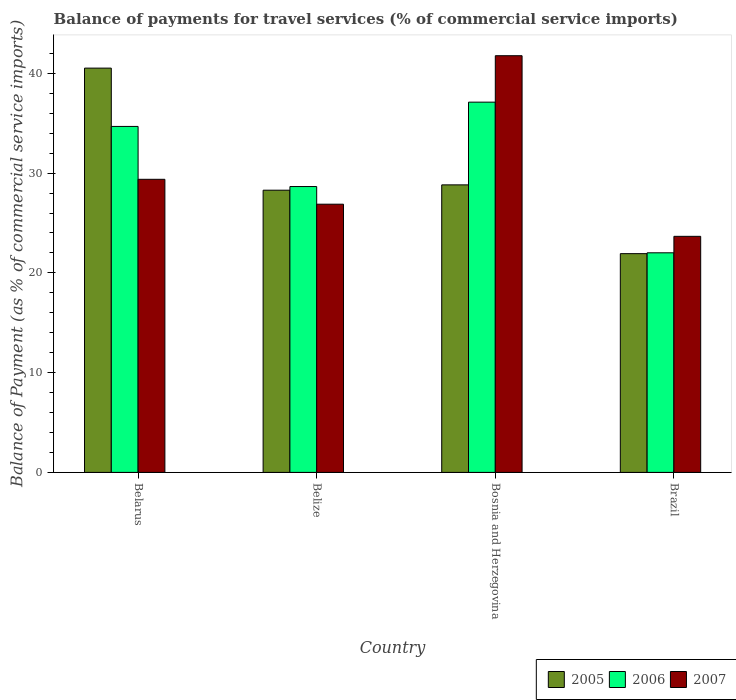How many groups of bars are there?
Provide a short and direct response. 4. How many bars are there on the 3rd tick from the left?
Give a very brief answer. 3. What is the label of the 3rd group of bars from the left?
Your response must be concise. Bosnia and Herzegovina. In how many cases, is the number of bars for a given country not equal to the number of legend labels?
Your response must be concise. 0. What is the balance of payments for travel services in 2005 in Bosnia and Herzegovina?
Ensure brevity in your answer.  28.82. Across all countries, what is the maximum balance of payments for travel services in 2006?
Your answer should be compact. 37.12. Across all countries, what is the minimum balance of payments for travel services in 2005?
Offer a terse response. 21.93. In which country was the balance of payments for travel services in 2006 maximum?
Keep it short and to the point. Bosnia and Herzegovina. What is the total balance of payments for travel services in 2006 in the graph?
Offer a very short reply. 122.47. What is the difference between the balance of payments for travel services in 2005 in Belize and that in Bosnia and Herzegovina?
Your answer should be very brief. -0.53. What is the difference between the balance of payments for travel services in 2005 in Brazil and the balance of payments for travel services in 2006 in Belize?
Provide a succinct answer. -6.73. What is the average balance of payments for travel services in 2006 per country?
Your response must be concise. 30.62. What is the difference between the balance of payments for travel services of/in 2007 and balance of payments for travel services of/in 2005 in Brazil?
Make the answer very short. 1.74. In how many countries, is the balance of payments for travel services in 2006 greater than 2 %?
Offer a very short reply. 4. What is the ratio of the balance of payments for travel services in 2007 in Belarus to that in Bosnia and Herzegovina?
Your answer should be compact. 0.7. Is the balance of payments for travel services in 2007 in Belize less than that in Bosnia and Herzegovina?
Provide a short and direct response. Yes. What is the difference between the highest and the second highest balance of payments for travel services in 2006?
Offer a terse response. 6.03. What is the difference between the highest and the lowest balance of payments for travel services in 2007?
Ensure brevity in your answer.  18.11. In how many countries, is the balance of payments for travel services in 2007 greater than the average balance of payments for travel services in 2007 taken over all countries?
Give a very brief answer. 1. How many bars are there?
Your response must be concise. 12. Are all the bars in the graph horizontal?
Your response must be concise. No. Are the values on the major ticks of Y-axis written in scientific E-notation?
Provide a succinct answer. No. Where does the legend appear in the graph?
Provide a succinct answer. Bottom right. How many legend labels are there?
Your answer should be very brief. 3. How are the legend labels stacked?
Give a very brief answer. Horizontal. What is the title of the graph?
Offer a very short reply. Balance of payments for travel services (% of commercial service imports). What is the label or title of the Y-axis?
Provide a succinct answer. Balance of Payment (as % of commercial service imports). What is the Balance of Payment (as % of commercial service imports) of 2005 in Belarus?
Provide a succinct answer. 40.53. What is the Balance of Payment (as % of commercial service imports) in 2006 in Belarus?
Your answer should be very brief. 34.68. What is the Balance of Payment (as % of commercial service imports) in 2007 in Belarus?
Give a very brief answer. 29.38. What is the Balance of Payment (as % of commercial service imports) of 2005 in Belize?
Your answer should be very brief. 28.29. What is the Balance of Payment (as % of commercial service imports) of 2006 in Belize?
Provide a short and direct response. 28.66. What is the Balance of Payment (as % of commercial service imports) of 2007 in Belize?
Offer a very short reply. 26.89. What is the Balance of Payment (as % of commercial service imports) in 2005 in Bosnia and Herzegovina?
Offer a terse response. 28.82. What is the Balance of Payment (as % of commercial service imports) of 2006 in Bosnia and Herzegovina?
Provide a succinct answer. 37.12. What is the Balance of Payment (as % of commercial service imports) of 2007 in Bosnia and Herzegovina?
Your response must be concise. 41.77. What is the Balance of Payment (as % of commercial service imports) of 2005 in Brazil?
Your response must be concise. 21.93. What is the Balance of Payment (as % of commercial service imports) of 2006 in Brazil?
Make the answer very short. 22.01. What is the Balance of Payment (as % of commercial service imports) of 2007 in Brazil?
Your response must be concise. 23.66. Across all countries, what is the maximum Balance of Payment (as % of commercial service imports) in 2005?
Ensure brevity in your answer.  40.53. Across all countries, what is the maximum Balance of Payment (as % of commercial service imports) of 2006?
Your answer should be very brief. 37.12. Across all countries, what is the maximum Balance of Payment (as % of commercial service imports) of 2007?
Keep it short and to the point. 41.77. Across all countries, what is the minimum Balance of Payment (as % of commercial service imports) in 2005?
Ensure brevity in your answer.  21.93. Across all countries, what is the minimum Balance of Payment (as % of commercial service imports) of 2006?
Keep it short and to the point. 22.01. Across all countries, what is the minimum Balance of Payment (as % of commercial service imports) of 2007?
Offer a terse response. 23.66. What is the total Balance of Payment (as % of commercial service imports) in 2005 in the graph?
Your response must be concise. 119.57. What is the total Balance of Payment (as % of commercial service imports) in 2006 in the graph?
Your response must be concise. 122.47. What is the total Balance of Payment (as % of commercial service imports) of 2007 in the graph?
Keep it short and to the point. 121.7. What is the difference between the Balance of Payment (as % of commercial service imports) in 2005 in Belarus and that in Belize?
Your answer should be very brief. 12.24. What is the difference between the Balance of Payment (as % of commercial service imports) of 2006 in Belarus and that in Belize?
Offer a terse response. 6.03. What is the difference between the Balance of Payment (as % of commercial service imports) of 2007 in Belarus and that in Belize?
Give a very brief answer. 2.49. What is the difference between the Balance of Payment (as % of commercial service imports) in 2005 in Belarus and that in Bosnia and Herzegovina?
Provide a succinct answer. 11.7. What is the difference between the Balance of Payment (as % of commercial service imports) in 2006 in Belarus and that in Bosnia and Herzegovina?
Provide a succinct answer. -2.43. What is the difference between the Balance of Payment (as % of commercial service imports) of 2007 in Belarus and that in Bosnia and Herzegovina?
Offer a terse response. -12.39. What is the difference between the Balance of Payment (as % of commercial service imports) in 2005 in Belarus and that in Brazil?
Your answer should be compact. 18.6. What is the difference between the Balance of Payment (as % of commercial service imports) in 2006 in Belarus and that in Brazil?
Make the answer very short. 12.67. What is the difference between the Balance of Payment (as % of commercial service imports) in 2007 in Belarus and that in Brazil?
Your response must be concise. 5.72. What is the difference between the Balance of Payment (as % of commercial service imports) in 2005 in Belize and that in Bosnia and Herzegovina?
Your answer should be very brief. -0.53. What is the difference between the Balance of Payment (as % of commercial service imports) in 2006 in Belize and that in Bosnia and Herzegovina?
Offer a very short reply. -8.46. What is the difference between the Balance of Payment (as % of commercial service imports) in 2007 in Belize and that in Bosnia and Herzegovina?
Provide a succinct answer. -14.88. What is the difference between the Balance of Payment (as % of commercial service imports) in 2005 in Belize and that in Brazil?
Offer a terse response. 6.36. What is the difference between the Balance of Payment (as % of commercial service imports) in 2006 in Belize and that in Brazil?
Give a very brief answer. 6.64. What is the difference between the Balance of Payment (as % of commercial service imports) in 2007 in Belize and that in Brazil?
Your response must be concise. 3.22. What is the difference between the Balance of Payment (as % of commercial service imports) of 2005 in Bosnia and Herzegovina and that in Brazil?
Ensure brevity in your answer.  6.9. What is the difference between the Balance of Payment (as % of commercial service imports) in 2006 in Bosnia and Herzegovina and that in Brazil?
Offer a very short reply. 15.1. What is the difference between the Balance of Payment (as % of commercial service imports) of 2007 in Bosnia and Herzegovina and that in Brazil?
Offer a terse response. 18.11. What is the difference between the Balance of Payment (as % of commercial service imports) of 2005 in Belarus and the Balance of Payment (as % of commercial service imports) of 2006 in Belize?
Your response must be concise. 11.87. What is the difference between the Balance of Payment (as % of commercial service imports) in 2005 in Belarus and the Balance of Payment (as % of commercial service imports) in 2007 in Belize?
Provide a succinct answer. 13.64. What is the difference between the Balance of Payment (as % of commercial service imports) in 2006 in Belarus and the Balance of Payment (as % of commercial service imports) in 2007 in Belize?
Offer a very short reply. 7.8. What is the difference between the Balance of Payment (as % of commercial service imports) of 2005 in Belarus and the Balance of Payment (as % of commercial service imports) of 2006 in Bosnia and Herzegovina?
Your answer should be very brief. 3.41. What is the difference between the Balance of Payment (as % of commercial service imports) of 2005 in Belarus and the Balance of Payment (as % of commercial service imports) of 2007 in Bosnia and Herzegovina?
Provide a succinct answer. -1.24. What is the difference between the Balance of Payment (as % of commercial service imports) in 2006 in Belarus and the Balance of Payment (as % of commercial service imports) in 2007 in Bosnia and Herzegovina?
Offer a terse response. -7.09. What is the difference between the Balance of Payment (as % of commercial service imports) of 2005 in Belarus and the Balance of Payment (as % of commercial service imports) of 2006 in Brazil?
Your answer should be very brief. 18.51. What is the difference between the Balance of Payment (as % of commercial service imports) in 2005 in Belarus and the Balance of Payment (as % of commercial service imports) in 2007 in Brazil?
Give a very brief answer. 16.86. What is the difference between the Balance of Payment (as % of commercial service imports) in 2006 in Belarus and the Balance of Payment (as % of commercial service imports) in 2007 in Brazil?
Ensure brevity in your answer.  11.02. What is the difference between the Balance of Payment (as % of commercial service imports) of 2005 in Belize and the Balance of Payment (as % of commercial service imports) of 2006 in Bosnia and Herzegovina?
Offer a terse response. -8.83. What is the difference between the Balance of Payment (as % of commercial service imports) of 2005 in Belize and the Balance of Payment (as % of commercial service imports) of 2007 in Bosnia and Herzegovina?
Give a very brief answer. -13.48. What is the difference between the Balance of Payment (as % of commercial service imports) in 2006 in Belize and the Balance of Payment (as % of commercial service imports) in 2007 in Bosnia and Herzegovina?
Ensure brevity in your answer.  -13.12. What is the difference between the Balance of Payment (as % of commercial service imports) in 2005 in Belize and the Balance of Payment (as % of commercial service imports) in 2006 in Brazil?
Provide a succinct answer. 6.28. What is the difference between the Balance of Payment (as % of commercial service imports) of 2005 in Belize and the Balance of Payment (as % of commercial service imports) of 2007 in Brazil?
Offer a very short reply. 4.63. What is the difference between the Balance of Payment (as % of commercial service imports) of 2006 in Belize and the Balance of Payment (as % of commercial service imports) of 2007 in Brazil?
Offer a very short reply. 4.99. What is the difference between the Balance of Payment (as % of commercial service imports) in 2005 in Bosnia and Herzegovina and the Balance of Payment (as % of commercial service imports) in 2006 in Brazil?
Ensure brevity in your answer.  6.81. What is the difference between the Balance of Payment (as % of commercial service imports) of 2005 in Bosnia and Herzegovina and the Balance of Payment (as % of commercial service imports) of 2007 in Brazil?
Offer a very short reply. 5.16. What is the difference between the Balance of Payment (as % of commercial service imports) of 2006 in Bosnia and Herzegovina and the Balance of Payment (as % of commercial service imports) of 2007 in Brazil?
Your answer should be compact. 13.45. What is the average Balance of Payment (as % of commercial service imports) of 2005 per country?
Your response must be concise. 29.89. What is the average Balance of Payment (as % of commercial service imports) in 2006 per country?
Provide a succinct answer. 30.62. What is the average Balance of Payment (as % of commercial service imports) of 2007 per country?
Offer a terse response. 30.43. What is the difference between the Balance of Payment (as % of commercial service imports) in 2005 and Balance of Payment (as % of commercial service imports) in 2006 in Belarus?
Provide a succinct answer. 5.85. What is the difference between the Balance of Payment (as % of commercial service imports) of 2005 and Balance of Payment (as % of commercial service imports) of 2007 in Belarus?
Offer a very short reply. 11.15. What is the difference between the Balance of Payment (as % of commercial service imports) in 2006 and Balance of Payment (as % of commercial service imports) in 2007 in Belarus?
Provide a short and direct response. 5.3. What is the difference between the Balance of Payment (as % of commercial service imports) in 2005 and Balance of Payment (as % of commercial service imports) in 2006 in Belize?
Provide a short and direct response. -0.37. What is the difference between the Balance of Payment (as % of commercial service imports) of 2005 and Balance of Payment (as % of commercial service imports) of 2007 in Belize?
Make the answer very short. 1.4. What is the difference between the Balance of Payment (as % of commercial service imports) in 2006 and Balance of Payment (as % of commercial service imports) in 2007 in Belize?
Provide a short and direct response. 1.77. What is the difference between the Balance of Payment (as % of commercial service imports) of 2005 and Balance of Payment (as % of commercial service imports) of 2006 in Bosnia and Herzegovina?
Provide a short and direct response. -8.29. What is the difference between the Balance of Payment (as % of commercial service imports) of 2005 and Balance of Payment (as % of commercial service imports) of 2007 in Bosnia and Herzegovina?
Offer a very short reply. -12.95. What is the difference between the Balance of Payment (as % of commercial service imports) of 2006 and Balance of Payment (as % of commercial service imports) of 2007 in Bosnia and Herzegovina?
Your response must be concise. -4.66. What is the difference between the Balance of Payment (as % of commercial service imports) of 2005 and Balance of Payment (as % of commercial service imports) of 2006 in Brazil?
Provide a succinct answer. -0.09. What is the difference between the Balance of Payment (as % of commercial service imports) of 2005 and Balance of Payment (as % of commercial service imports) of 2007 in Brazil?
Provide a short and direct response. -1.74. What is the difference between the Balance of Payment (as % of commercial service imports) of 2006 and Balance of Payment (as % of commercial service imports) of 2007 in Brazil?
Your response must be concise. -1.65. What is the ratio of the Balance of Payment (as % of commercial service imports) of 2005 in Belarus to that in Belize?
Your answer should be compact. 1.43. What is the ratio of the Balance of Payment (as % of commercial service imports) in 2006 in Belarus to that in Belize?
Your answer should be compact. 1.21. What is the ratio of the Balance of Payment (as % of commercial service imports) in 2007 in Belarus to that in Belize?
Ensure brevity in your answer.  1.09. What is the ratio of the Balance of Payment (as % of commercial service imports) of 2005 in Belarus to that in Bosnia and Herzegovina?
Your response must be concise. 1.41. What is the ratio of the Balance of Payment (as % of commercial service imports) in 2006 in Belarus to that in Bosnia and Herzegovina?
Give a very brief answer. 0.93. What is the ratio of the Balance of Payment (as % of commercial service imports) of 2007 in Belarus to that in Bosnia and Herzegovina?
Provide a succinct answer. 0.7. What is the ratio of the Balance of Payment (as % of commercial service imports) of 2005 in Belarus to that in Brazil?
Provide a short and direct response. 1.85. What is the ratio of the Balance of Payment (as % of commercial service imports) of 2006 in Belarus to that in Brazil?
Ensure brevity in your answer.  1.58. What is the ratio of the Balance of Payment (as % of commercial service imports) of 2007 in Belarus to that in Brazil?
Provide a succinct answer. 1.24. What is the ratio of the Balance of Payment (as % of commercial service imports) in 2005 in Belize to that in Bosnia and Herzegovina?
Your response must be concise. 0.98. What is the ratio of the Balance of Payment (as % of commercial service imports) in 2006 in Belize to that in Bosnia and Herzegovina?
Make the answer very short. 0.77. What is the ratio of the Balance of Payment (as % of commercial service imports) of 2007 in Belize to that in Bosnia and Herzegovina?
Your answer should be very brief. 0.64. What is the ratio of the Balance of Payment (as % of commercial service imports) of 2005 in Belize to that in Brazil?
Offer a terse response. 1.29. What is the ratio of the Balance of Payment (as % of commercial service imports) of 2006 in Belize to that in Brazil?
Make the answer very short. 1.3. What is the ratio of the Balance of Payment (as % of commercial service imports) in 2007 in Belize to that in Brazil?
Your answer should be very brief. 1.14. What is the ratio of the Balance of Payment (as % of commercial service imports) of 2005 in Bosnia and Herzegovina to that in Brazil?
Give a very brief answer. 1.31. What is the ratio of the Balance of Payment (as % of commercial service imports) in 2006 in Bosnia and Herzegovina to that in Brazil?
Make the answer very short. 1.69. What is the ratio of the Balance of Payment (as % of commercial service imports) in 2007 in Bosnia and Herzegovina to that in Brazil?
Provide a succinct answer. 1.77. What is the difference between the highest and the second highest Balance of Payment (as % of commercial service imports) of 2005?
Offer a very short reply. 11.7. What is the difference between the highest and the second highest Balance of Payment (as % of commercial service imports) of 2006?
Provide a short and direct response. 2.43. What is the difference between the highest and the second highest Balance of Payment (as % of commercial service imports) in 2007?
Provide a succinct answer. 12.39. What is the difference between the highest and the lowest Balance of Payment (as % of commercial service imports) in 2005?
Make the answer very short. 18.6. What is the difference between the highest and the lowest Balance of Payment (as % of commercial service imports) of 2006?
Ensure brevity in your answer.  15.1. What is the difference between the highest and the lowest Balance of Payment (as % of commercial service imports) in 2007?
Offer a terse response. 18.11. 